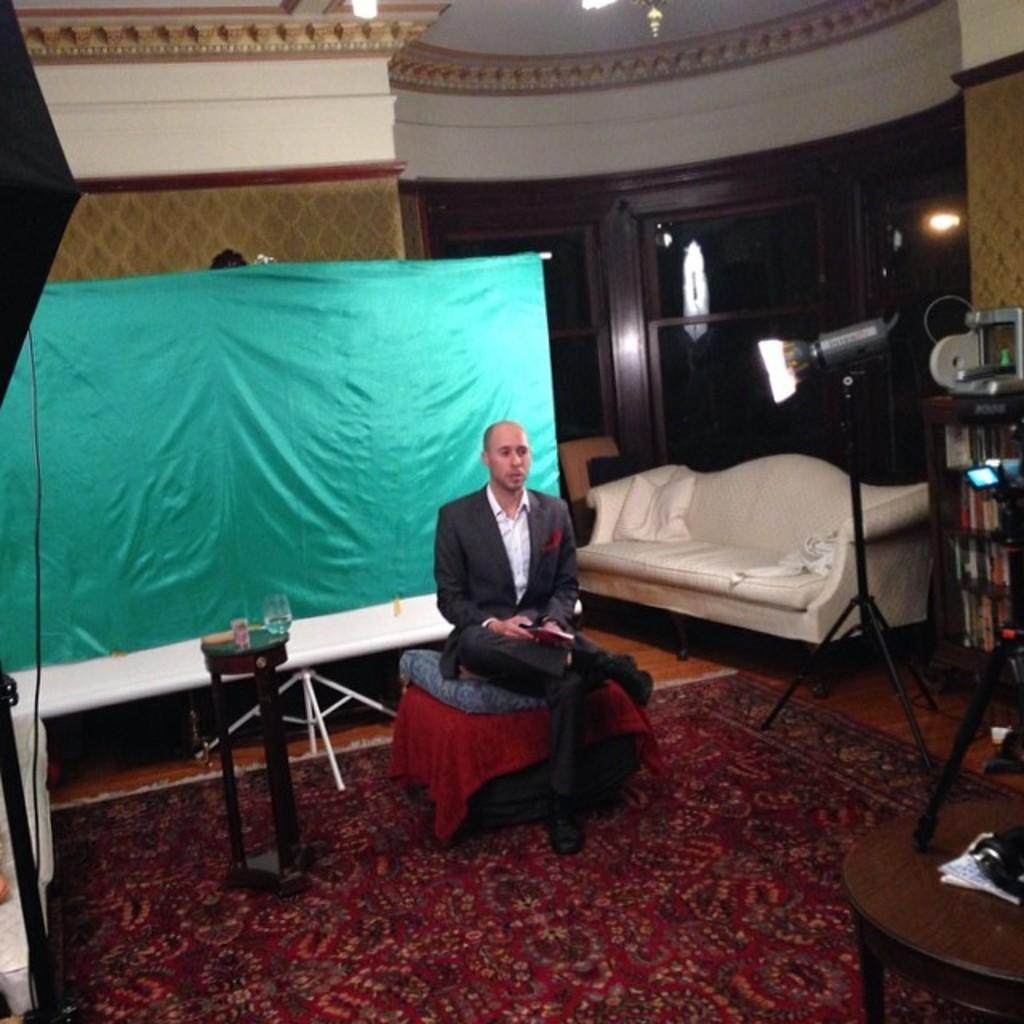Please provide a concise description of this image. In this image,There is a floor which is in red color and in the middle there is a man sitting on the table which is covered by a red color cloth, In the left side there is a black color object and in the background there is a blue color wall. 